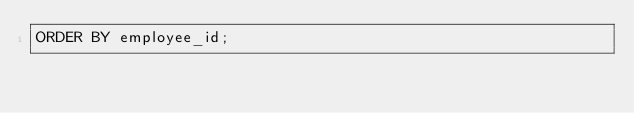<code> <loc_0><loc_0><loc_500><loc_500><_SQL_>ORDER BY employee_id;
</code> 